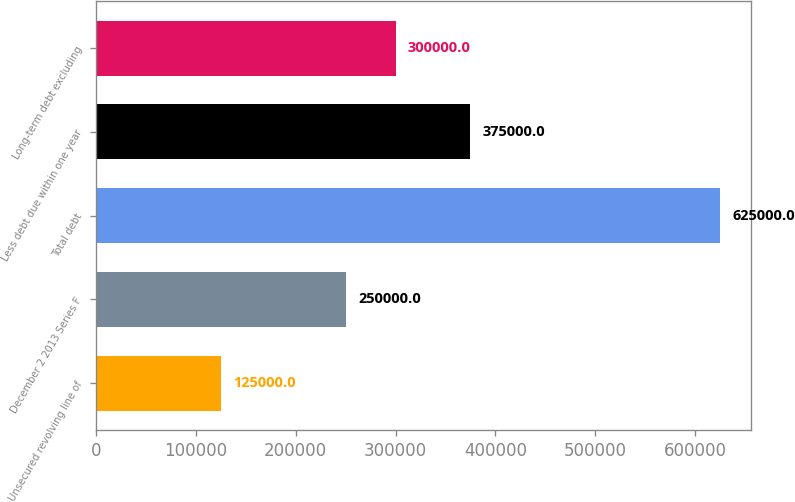<chart> <loc_0><loc_0><loc_500><loc_500><bar_chart><fcel>Unsecured revolving line of<fcel>December 2 2013 Series F<fcel>Total debt<fcel>Less debt due within one year<fcel>Long-term debt excluding<nl><fcel>125000<fcel>250000<fcel>625000<fcel>375000<fcel>300000<nl></chart> 